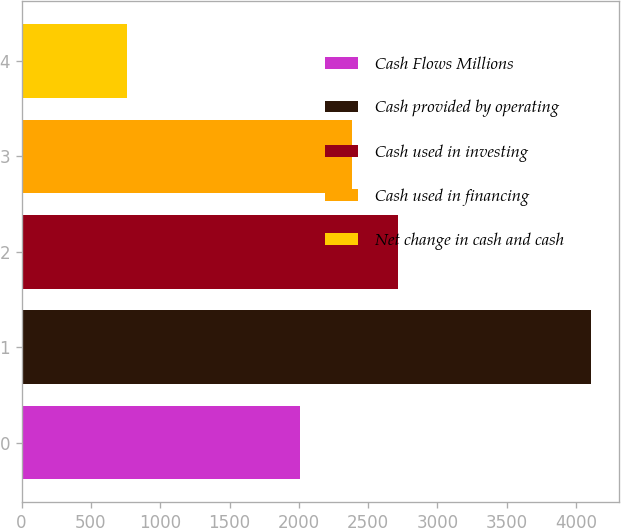<chart> <loc_0><loc_0><loc_500><loc_500><bar_chart><fcel>Cash Flows Millions<fcel>Cash provided by operating<fcel>Cash used in investing<fcel>Cash used in financing<fcel>Net change in cash and cash<nl><fcel>2010<fcel>4105<fcel>2715.1<fcel>2381<fcel>764<nl></chart> 